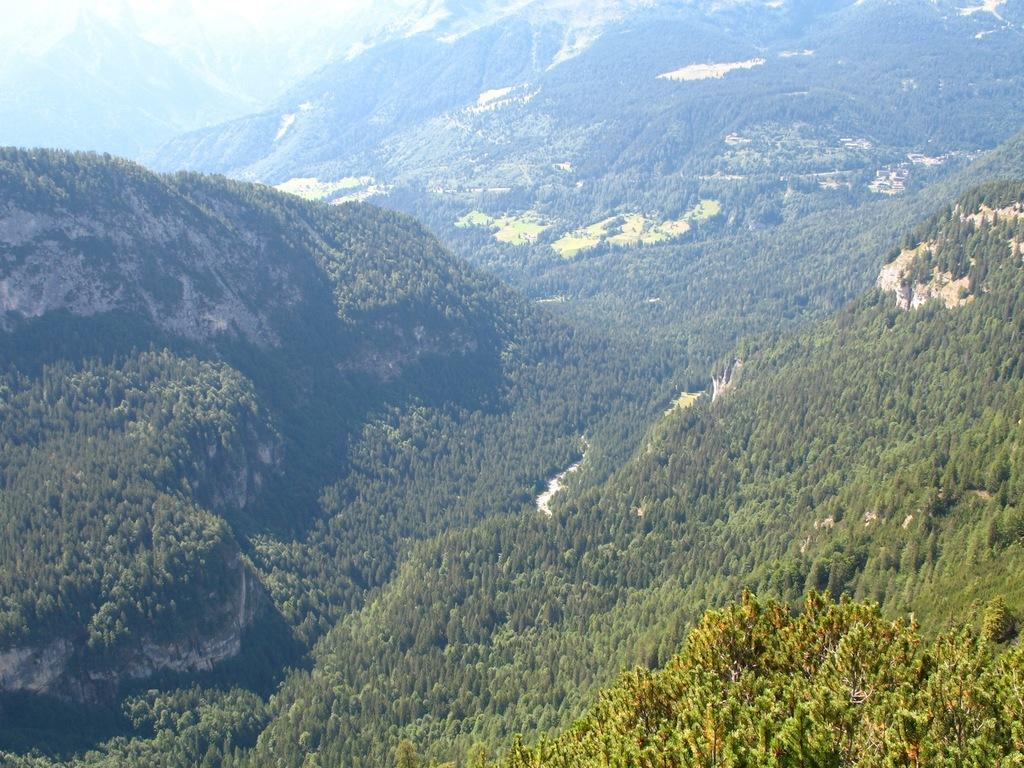Where was the image taken? The image was taken in the mountains. What type of vegetation can be seen in the image? There are trees in the image. What geographical feature is prominently featured in the image? There are mountains in the image. What is the weather like in the image? It is sunny in the image. What class of animals can be seen blowing bubbles in the image? There are no animals blowing bubbles in the image; it features mountains and trees. What type of ground is visible in the image? The ground is not specifically mentioned in the image, but it is likely to be mountainous terrain. 